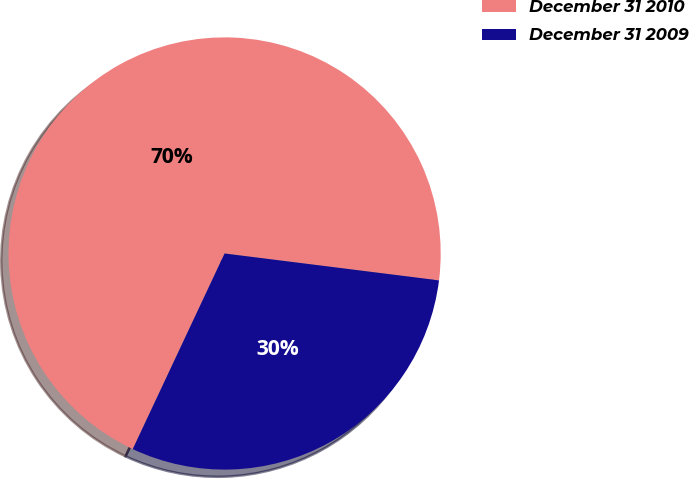<chart> <loc_0><loc_0><loc_500><loc_500><pie_chart><fcel>December 31 2010<fcel>December 31 2009<nl><fcel>70.0%<fcel>30.0%<nl></chart> 